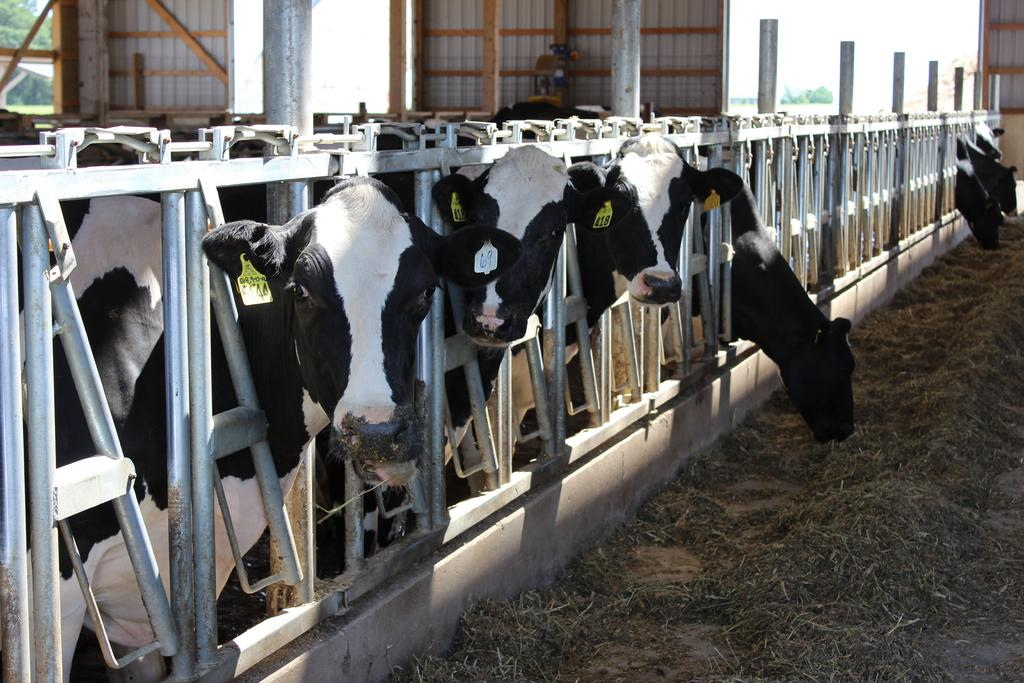What type of animals can be seen in the image? There are cattle in the image. Where are the cattle located? The cattle are in a dairy farm. What is used to contain the cattle in the image? There is fencing in the image. What type of vegetation is visible in front of the cattle? There is grass in front of the cattle. What structures can be seen in the background of the image? There are sheds in the background of the image. What color is the hydrant near the cattle in the image? There is no hydrant present in the image. How does the cattle's temperament affect the list of tasks for the day? There is no list of tasks mentioned in the image, and the cattle's temperament cannot be determined from the image. 